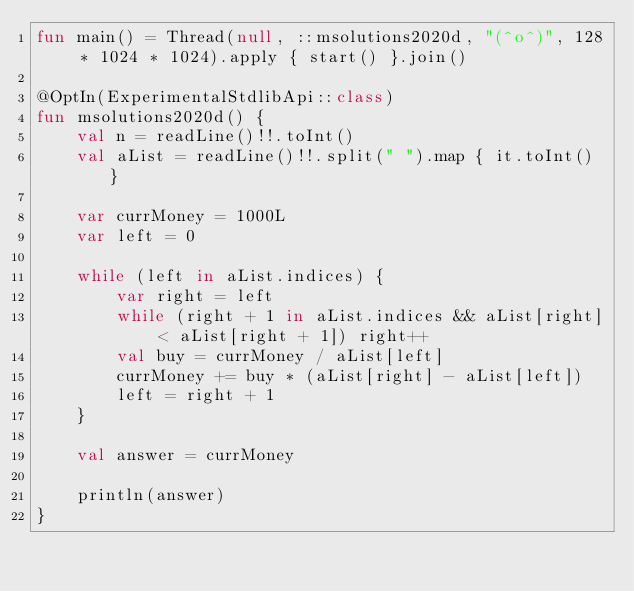Convert code to text. <code><loc_0><loc_0><loc_500><loc_500><_Kotlin_>fun main() = Thread(null, ::msolutions2020d, "(^o^)", 128 * 1024 * 1024).apply { start() }.join()

@OptIn(ExperimentalStdlibApi::class)
fun msolutions2020d() {
    val n = readLine()!!.toInt()
    val aList = readLine()!!.split(" ").map { it.toInt() }

    var currMoney = 1000L
    var left = 0

    while (left in aList.indices) {
        var right = left
        while (right + 1 in aList.indices && aList[right] < aList[right + 1]) right++
        val buy = currMoney / aList[left]
        currMoney += buy * (aList[right] - aList[left])
        left = right + 1
    }

    val answer = currMoney

    println(answer)
}
</code> 